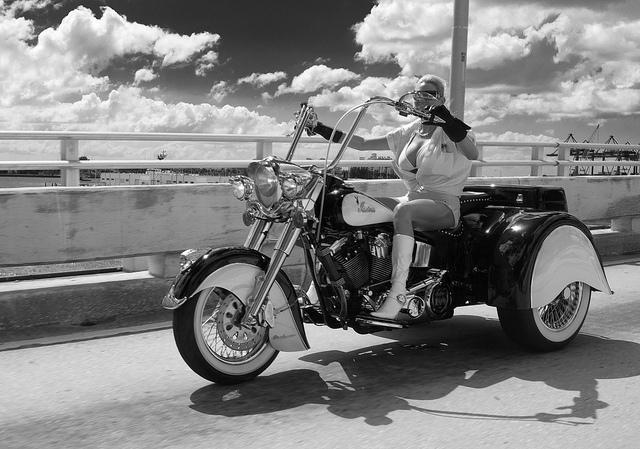How many tires does the bike have?
Give a very brief answer. 3. How many giraffes are there?
Give a very brief answer. 0. 